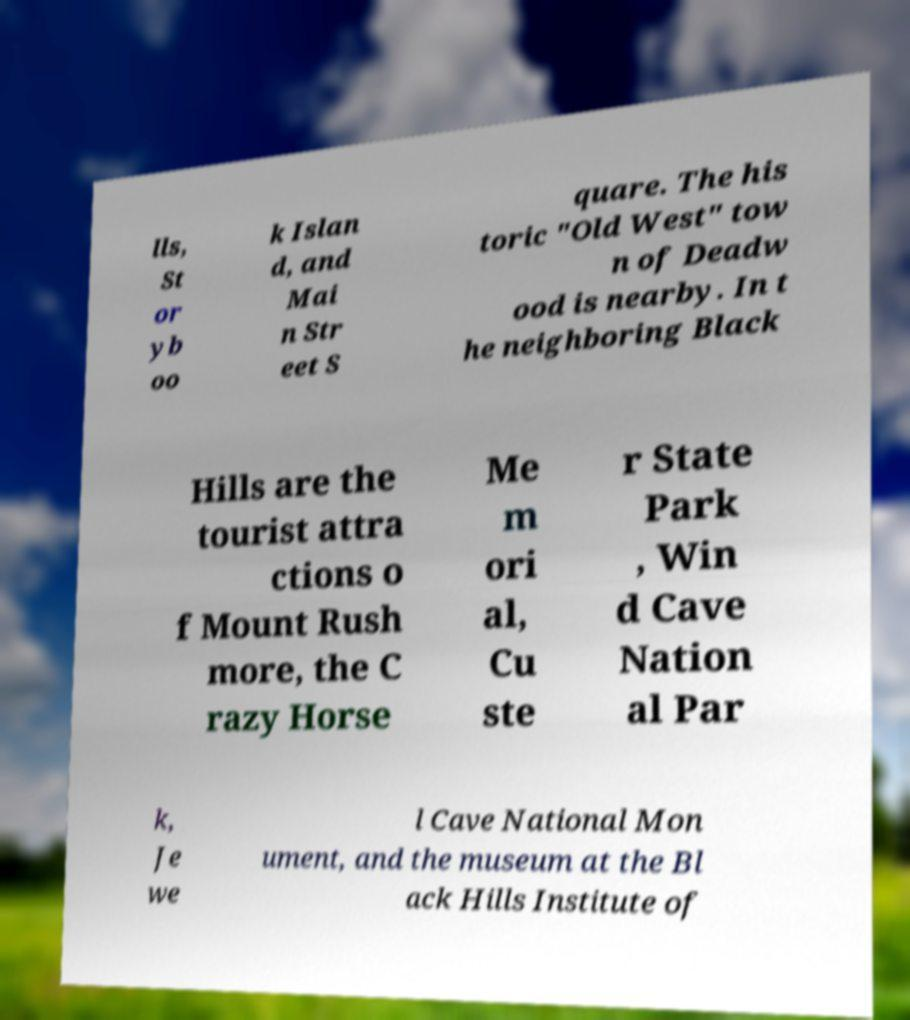Please identify and transcribe the text found in this image. lls, St or yb oo k Islan d, and Mai n Str eet S quare. The his toric "Old West" tow n of Deadw ood is nearby. In t he neighboring Black Hills are the tourist attra ctions o f Mount Rush more, the C razy Horse Me m ori al, Cu ste r State Park , Win d Cave Nation al Par k, Je we l Cave National Mon ument, and the museum at the Bl ack Hills Institute of 